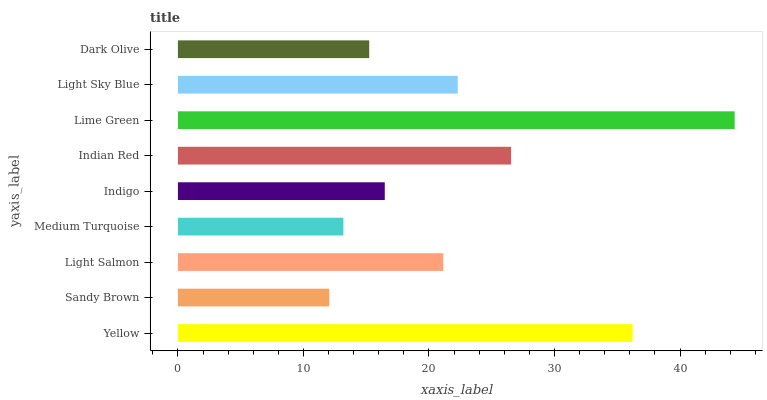Is Sandy Brown the minimum?
Answer yes or no. Yes. Is Lime Green the maximum?
Answer yes or no. Yes. Is Light Salmon the minimum?
Answer yes or no. No. Is Light Salmon the maximum?
Answer yes or no. No. Is Light Salmon greater than Sandy Brown?
Answer yes or no. Yes. Is Sandy Brown less than Light Salmon?
Answer yes or no. Yes. Is Sandy Brown greater than Light Salmon?
Answer yes or no. No. Is Light Salmon less than Sandy Brown?
Answer yes or no. No. Is Light Salmon the high median?
Answer yes or no. Yes. Is Light Salmon the low median?
Answer yes or no. Yes. Is Indian Red the high median?
Answer yes or no. No. Is Dark Olive the low median?
Answer yes or no. No. 